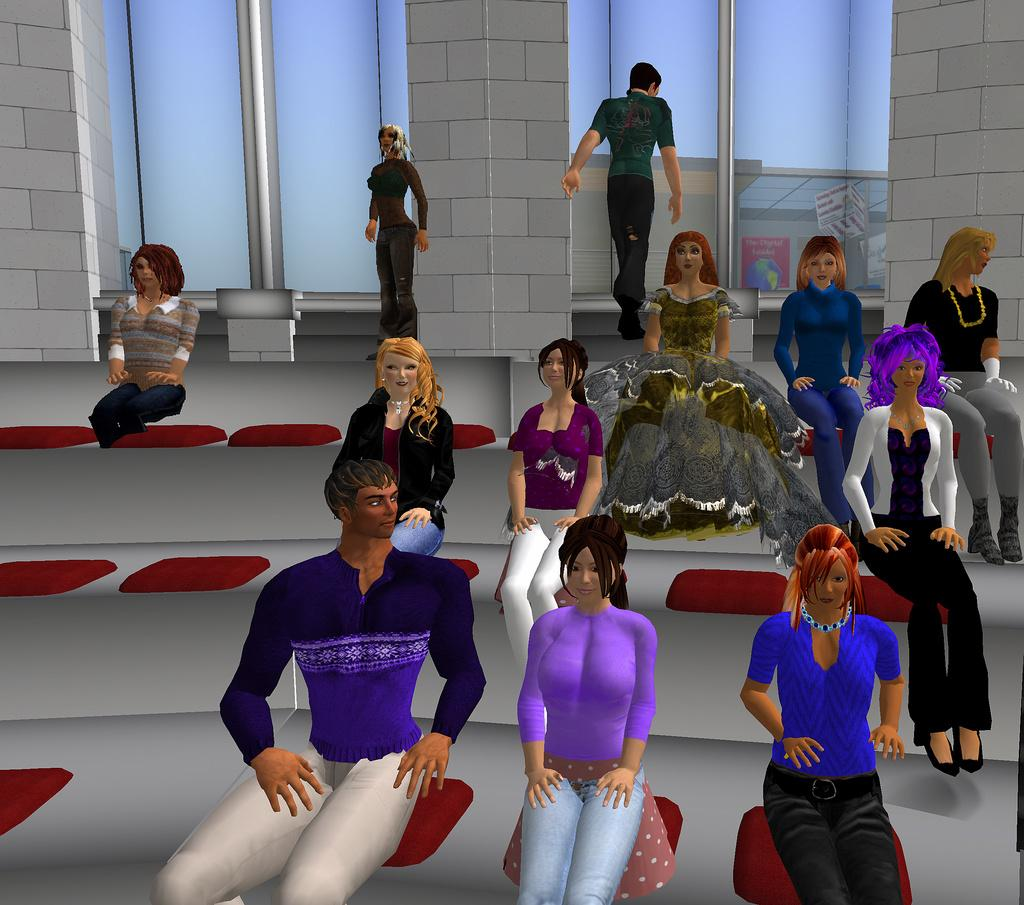What type of image is being described? The image is an animated picture. What are the people in the image doing? There is a group of people sitting in the image. What is the action of one person in the image? A man is walking in the image. Can you describe the position of another person in the image? Another person is standing on a path in the image. What is located behind the people in the image? There is a wall behind the people in the image. What type of regret can be seen on the faces of the people in the image? There is no indication of regret on the faces of the people in the image; they are simply sitting or standing. How many snakes are slithering around the people in the image? There are no snakes present in the image. 